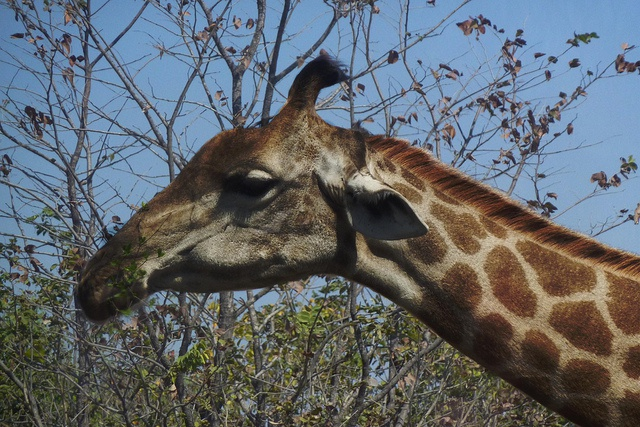Describe the objects in this image and their specific colors. I can see a giraffe in gray, black, and maroon tones in this image. 